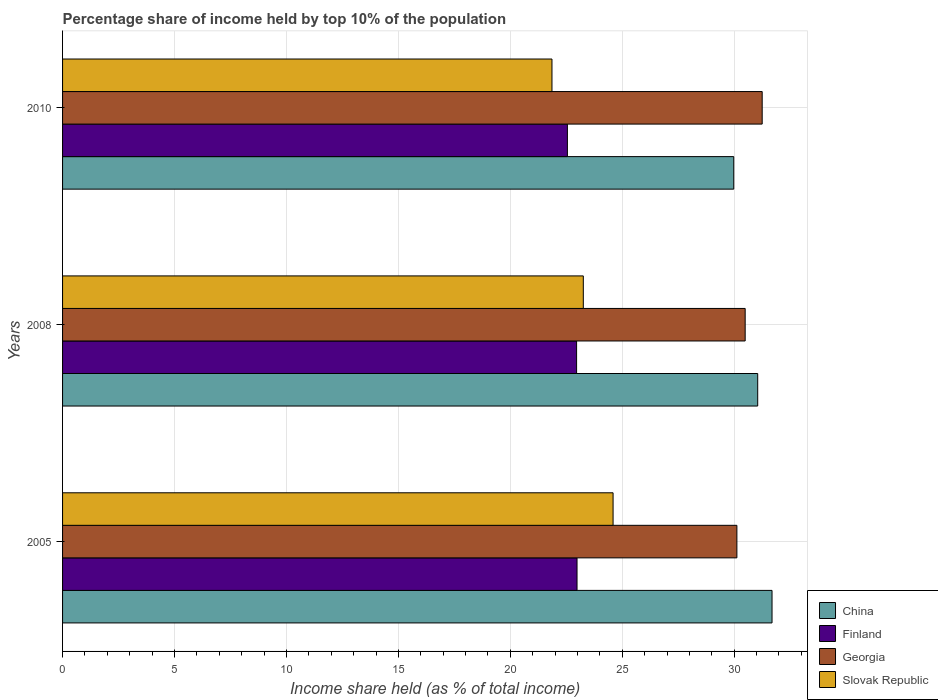How many groups of bars are there?
Offer a terse response. 3. Are the number of bars per tick equal to the number of legend labels?
Give a very brief answer. Yes. How many bars are there on the 3rd tick from the top?
Provide a short and direct response. 4. What is the label of the 1st group of bars from the top?
Your response must be concise. 2010. In how many cases, is the number of bars for a given year not equal to the number of legend labels?
Keep it short and to the point. 0. What is the percentage share of income held by top 10% of the population in China in 2005?
Your response must be concise. 31.69. Across all years, what is the maximum percentage share of income held by top 10% of the population in Slovak Republic?
Keep it short and to the point. 24.59. Across all years, what is the minimum percentage share of income held by top 10% of the population in Georgia?
Offer a very short reply. 30.12. In which year was the percentage share of income held by top 10% of the population in China minimum?
Provide a succinct answer. 2010. What is the total percentage share of income held by top 10% of the population in Finland in the graph?
Provide a succinct answer. 68.49. What is the difference between the percentage share of income held by top 10% of the population in Slovak Republic in 2008 and that in 2010?
Ensure brevity in your answer.  1.4. What is the difference between the percentage share of income held by top 10% of the population in Georgia in 2010 and the percentage share of income held by top 10% of the population in Finland in 2008?
Provide a short and direct response. 8.29. What is the average percentage share of income held by top 10% of the population in China per year?
Ensure brevity in your answer.  30.91. In the year 2008, what is the difference between the percentage share of income held by top 10% of the population in Finland and percentage share of income held by top 10% of the population in China?
Offer a very short reply. -8.09. In how many years, is the percentage share of income held by top 10% of the population in Georgia greater than 14 %?
Your response must be concise. 3. What is the ratio of the percentage share of income held by top 10% of the population in Slovak Republic in 2005 to that in 2010?
Your answer should be very brief. 1.12. Is the difference between the percentage share of income held by top 10% of the population in Finland in 2005 and 2008 greater than the difference between the percentage share of income held by top 10% of the population in China in 2005 and 2008?
Provide a succinct answer. No. What is the difference between the highest and the second highest percentage share of income held by top 10% of the population in China?
Ensure brevity in your answer.  0.64. What is the difference between the highest and the lowest percentage share of income held by top 10% of the population in Slovak Republic?
Your answer should be compact. 2.73. What does the 3rd bar from the top in 2008 represents?
Offer a terse response. Finland. What does the 2nd bar from the bottom in 2008 represents?
Keep it short and to the point. Finland. Are all the bars in the graph horizontal?
Your response must be concise. Yes. What is the difference between two consecutive major ticks on the X-axis?
Offer a very short reply. 5. Are the values on the major ticks of X-axis written in scientific E-notation?
Offer a very short reply. No. Where does the legend appear in the graph?
Ensure brevity in your answer.  Bottom right. How many legend labels are there?
Keep it short and to the point. 4. How are the legend labels stacked?
Give a very brief answer. Vertical. What is the title of the graph?
Provide a succinct answer. Percentage share of income held by top 10% of the population. Does "Virgin Islands" appear as one of the legend labels in the graph?
Give a very brief answer. No. What is the label or title of the X-axis?
Your answer should be very brief. Income share held (as % of total income). What is the Income share held (as % of total income) in China in 2005?
Your answer should be compact. 31.69. What is the Income share held (as % of total income) in Finland in 2005?
Provide a short and direct response. 22.98. What is the Income share held (as % of total income) of Georgia in 2005?
Your answer should be very brief. 30.12. What is the Income share held (as % of total income) of Slovak Republic in 2005?
Your answer should be very brief. 24.59. What is the Income share held (as % of total income) of China in 2008?
Offer a very short reply. 31.05. What is the Income share held (as % of total income) in Finland in 2008?
Provide a succinct answer. 22.96. What is the Income share held (as % of total income) in Georgia in 2008?
Offer a very short reply. 30.49. What is the Income share held (as % of total income) in Slovak Republic in 2008?
Offer a very short reply. 23.26. What is the Income share held (as % of total income) in China in 2010?
Your answer should be compact. 29.98. What is the Income share held (as % of total income) of Finland in 2010?
Your answer should be compact. 22.55. What is the Income share held (as % of total income) in Georgia in 2010?
Offer a very short reply. 31.25. What is the Income share held (as % of total income) of Slovak Republic in 2010?
Ensure brevity in your answer.  21.86. Across all years, what is the maximum Income share held (as % of total income) in China?
Give a very brief answer. 31.69. Across all years, what is the maximum Income share held (as % of total income) in Finland?
Offer a very short reply. 22.98. Across all years, what is the maximum Income share held (as % of total income) of Georgia?
Your response must be concise. 31.25. Across all years, what is the maximum Income share held (as % of total income) in Slovak Republic?
Offer a very short reply. 24.59. Across all years, what is the minimum Income share held (as % of total income) of China?
Offer a terse response. 29.98. Across all years, what is the minimum Income share held (as % of total income) of Finland?
Keep it short and to the point. 22.55. Across all years, what is the minimum Income share held (as % of total income) of Georgia?
Offer a very short reply. 30.12. Across all years, what is the minimum Income share held (as % of total income) in Slovak Republic?
Provide a succinct answer. 21.86. What is the total Income share held (as % of total income) in China in the graph?
Your answer should be very brief. 92.72. What is the total Income share held (as % of total income) in Finland in the graph?
Keep it short and to the point. 68.49. What is the total Income share held (as % of total income) of Georgia in the graph?
Ensure brevity in your answer.  91.86. What is the total Income share held (as % of total income) in Slovak Republic in the graph?
Provide a short and direct response. 69.71. What is the difference between the Income share held (as % of total income) of China in 2005 and that in 2008?
Provide a short and direct response. 0.64. What is the difference between the Income share held (as % of total income) of Georgia in 2005 and that in 2008?
Offer a terse response. -0.37. What is the difference between the Income share held (as % of total income) of Slovak Republic in 2005 and that in 2008?
Ensure brevity in your answer.  1.33. What is the difference between the Income share held (as % of total income) in China in 2005 and that in 2010?
Provide a short and direct response. 1.71. What is the difference between the Income share held (as % of total income) in Finland in 2005 and that in 2010?
Your response must be concise. 0.43. What is the difference between the Income share held (as % of total income) in Georgia in 2005 and that in 2010?
Provide a short and direct response. -1.13. What is the difference between the Income share held (as % of total income) in Slovak Republic in 2005 and that in 2010?
Ensure brevity in your answer.  2.73. What is the difference between the Income share held (as % of total income) in China in 2008 and that in 2010?
Offer a very short reply. 1.07. What is the difference between the Income share held (as % of total income) of Finland in 2008 and that in 2010?
Offer a terse response. 0.41. What is the difference between the Income share held (as % of total income) in Georgia in 2008 and that in 2010?
Your answer should be compact. -0.76. What is the difference between the Income share held (as % of total income) of China in 2005 and the Income share held (as % of total income) of Finland in 2008?
Make the answer very short. 8.73. What is the difference between the Income share held (as % of total income) in China in 2005 and the Income share held (as % of total income) in Georgia in 2008?
Provide a short and direct response. 1.2. What is the difference between the Income share held (as % of total income) in China in 2005 and the Income share held (as % of total income) in Slovak Republic in 2008?
Offer a terse response. 8.43. What is the difference between the Income share held (as % of total income) of Finland in 2005 and the Income share held (as % of total income) of Georgia in 2008?
Offer a terse response. -7.51. What is the difference between the Income share held (as % of total income) in Finland in 2005 and the Income share held (as % of total income) in Slovak Republic in 2008?
Ensure brevity in your answer.  -0.28. What is the difference between the Income share held (as % of total income) in Georgia in 2005 and the Income share held (as % of total income) in Slovak Republic in 2008?
Offer a terse response. 6.86. What is the difference between the Income share held (as % of total income) of China in 2005 and the Income share held (as % of total income) of Finland in 2010?
Make the answer very short. 9.14. What is the difference between the Income share held (as % of total income) in China in 2005 and the Income share held (as % of total income) in Georgia in 2010?
Offer a very short reply. 0.44. What is the difference between the Income share held (as % of total income) in China in 2005 and the Income share held (as % of total income) in Slovak Republic in 2010?
Keep it short and to the point. 9.83. What is the difference between the Income share held (as % of total income) in Finland in 2005 and the Income share held (as % of total income) in Georgia in 2010?
Offer a terse response. -8.27. What is the difference between the Income share held (as % of total income) of Finland in 2005 and the Income share held (as % of total income) of Slovak Republic in 2010?
Offer a very short reply. 1.12. What is the difference between the Income share held (as % of total income) of Georgia in 2005 and the Income share held (as % of total income) of Slovak Republic in 2010?
Your answer should be compact. 8.26. What is the difference between the Income share held (as % of total income) of China in 2008 and the Income share held (as % of total income) of Slovak Republic in 2010?
Ensure brevity in your answer.  9.19. What is the difference between the Income share held (as % of total income) in Finland in 2008 and the Income share held (as % of total income) in Georgia in 2010?
Your answer should be compact. -8.29. What is the difference between the Income share held (as % of total income) of Finland in 2008 and the Income share held (as % of total income) of Slovak Republic in 2010?
Your response must be concise. 1.1. What is the difference between the Income share held (as % of total income) of Georgia in 2008 and the Income share held (as % of total income) of Slovak Republic in 2010?
Your answer should be very brief. 8.63. What is the average Income share held (as % of total income) in China per year?
Offer a terse response. 30.91. What is the average Income share held (as % of total income) in Finland per year?
Your answer should be compact. 22.83. What is the average Income share held (as % of total income) in Georgia per year?
Offer a terse response. 30.62. What is the average Income share held (as % of total income) in Slovak Republic per year?
Give a very brief answer. 23.24. In the year 2005, what is the difference between the Income share held (as % of total income) of China and Income share held (as % of total income) of Finland?
Ensure brevity in your answer.  8.71. In the year 2005, what is the difference between the Income share held (as % of total income) of China and Income share held (as % of total income) of Georgia?
Provide a succinct answer. 1.57. In the year 2005, what is the difference between the Income share held (as % of total income) in China and Income share held (as % of total income) in Slovak Republic?
Make the answer very short. 7.1. In the year 2005, what is the difference between the Income share held (as % of total income) in Finland and Income share held (as % of total income) in Georgia?
Provide a succinct answer. -7.14. In the year 2005, what is the difference between the Income share held (as % of total income) of Finland and Income share held (as % of total income) of Slovak Republic?
Give a very brief answer. -1.61. In the year 2005, what is the difference between the Income share held (as % of total income) of Georgia and Income share held (as % of total income) of Slovak Republic?
Give a very brief answer. 5.53. In the year 2008, what is the difference between the Income share held (as % of total income) of China and Income share held (as % of total income) of Finland?
Your answer should be very brief. 8.09. In the year 2008, what is the difference between the Income share held (as % of total income) of China and Income share held (as % of total income) of Georgia?
Keep it short and to the point. 0.56. In the year 2008, what is the difference between the Income share held (as % of total income) in China and Income share held (as % of total income) in Slovak Republic?
Ensure brevity in your answer.  7.79. In the year 2008, what is the difference between the Income share held (as % of total income) of Finland and Income share held (as % of total income) of Georgia?
Provide a succinct answer. -7.53. In the year 2008, what is the difference between the Income share held (as % of total income) of Finland and Income share held (as % of total income) of Slovak Republic?
Your answer should be compact. -0.3. In the year 2008, what is the difference between the Income share held (as % of total income) in Georgia and Income share held (as % of total income) in Slovak Republic?
Keep it short and to the point. 7.23. In the year 2010, what is the difference between the Income share held (as % of total income) in China and Income share held (as % of total income) in Finland?
Keep it short and to the point. 7.43. In the year 2010, what is the difference between the Income share held (as % of total income) in China and Income share held (as % of total income) in Georgia?
Your answer should be compact. -1.27. In the year 2010, what is the difference between the Income share held (as % of total income) in China and Income share held (as % of total income) in Slovak Republic?
Your answer should be compact. 8.12. In the year 2010, what is the difference between the Income share held (as % of total income) in Finland and Income share held (as % of total income) in Slovak Republic?
Provide a succinct answer. 0.69. In the year 2010, what is the difference between the Income share held (as % of total income) in Georgia and Income share held (as % of total income) in Slovak Republic?
Give a very brief answer. 9.39. What is the ratio of the Income share held (as % of total income) in China in 2005 to that in 2008?
Provide a short and direct response. 1.02. What is the ratio of the Income share held (as % of total income) in Finland in 2005 to that in 2008?
Give a very brief answer. 1. What is the ratio of the Income share held (as % of total income) of Georgia in 2005 to that in 2008?
Provide a succinct answer. 0.99. What is the ratio of the Income share held (as % of total income) of Slovak Republic in 2005 to that in 2008?
Keep it short and to the point. 1.06. What is the ratio of the Income share held (as % of total income) in China in 2005 to that in 2010?
Provide a succinct answer. 1.06. What is the ratio of the Income share held (as % of total income) in Finland in 2005 to that in 2010?
Give a very brief answer. 1.02. What is the ratio of the Income share held (as % of total income) of Georgia in 2005 to that in 2010?
Give a very brief answer. 0.96. What is the ratio of the Income share held (as % of total income) of Slovak Republic in 2005 to that in 2010?
Ensure brevity in your answer.  1.12. What is the ratio of the Income share held (as % of total income) of China in 2008 to that in 2010?
Keep it short and to the point. 1.04. What is the ratio of the Income share held (as % of total income) in Finland in 2008 to that in 2010?
Your response must be concise. 1.02. What is the ratio of the Income share held (as % of total income) of Georgia in 2008 to that in 2010?
Make the answer very short. 0.98. What is the ratio of the Income share held (as % of total income) of Slovak Republic in 2008 to that in 2010?
Your answer should be very brief. 1.06. What is the difference between the highest and the second highest Income share held (as % of total income) of China?
Offer a terse response. 0.64. What is the difference between the highest and the second highest Income share held (as % of total income) of Finland?
Provide a short and direct response. 0.02. What is the difference between the highest and the second highest Income share held (as % of total income) in Georgia?
Your response must be concise. 0.76. What is the difference between the highest and the second highest Income share held (as % of total income) of Slovak Republic?
Keep it short and to the point. 1.33. What is the difference between the highest and the lowest Income share held (as % of total income) in China?
Ensure brevity in your answer.  1.71. What is the difference between the highest and the lowest Income share held (as % of total income) of Finland?
Your answer should be very brief. 0.43. What is the difference between the highest and the lowest Income share held (as % of total income) in Georgia?
Provide a short and direct response. 1.13. What is the difference between the highest and the lowest Income share held (as % of total income) of Slovak Republic?
Make the answer very short. 2.73. 